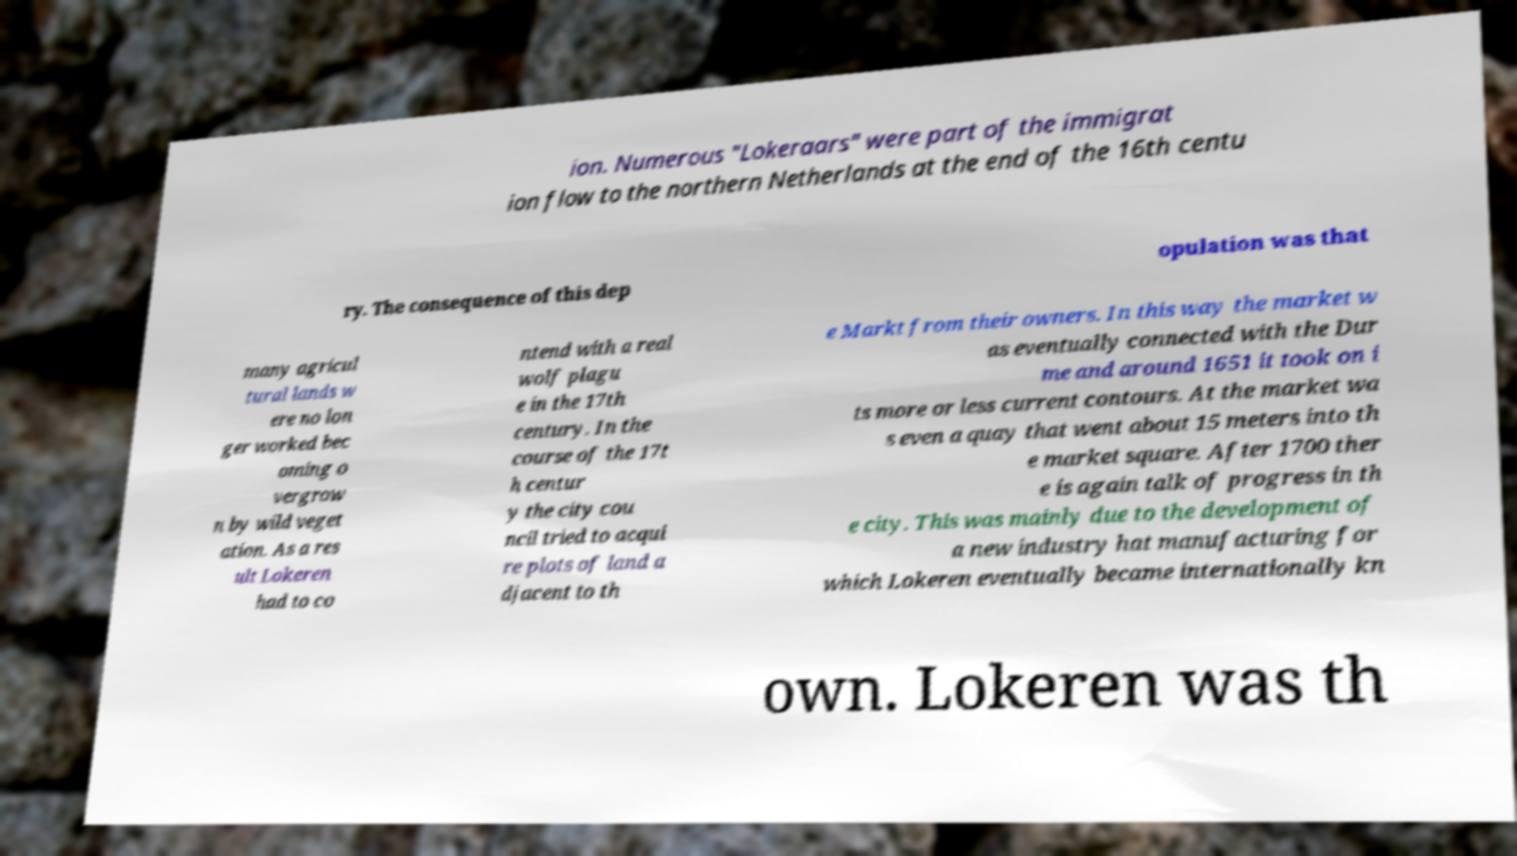I need the written content from this picture converted into text. Can you do that? ion. Numerous "Lokeraars" were part of the immigrat ion flow to the northern Netherlands at the end of the 16th centu ry. The consequence of this dep opulation was that many agricul tural lands w ere no lon ger worked bec oming o vergrow n by wild veget ation. As a res ult Lokeren had to co ntend with a real wolf plagu e in the 17th century. In the course of the 17t h centur y the city cou ncil tried to acqui re plots of land a djacent to th e Markt from their owners. In this way the market w as eventually connected with the Dur me and around 1651 it took on i ts more or less current contours. At the market wa s even a quay that went about 15 meters into th e market square. After 1700 ther e is again talk of progress in th e city. This was mainly due to the development of a new industry hat manufacturing for which Lokeren eventually became internationally kn own. Lokeren was th 